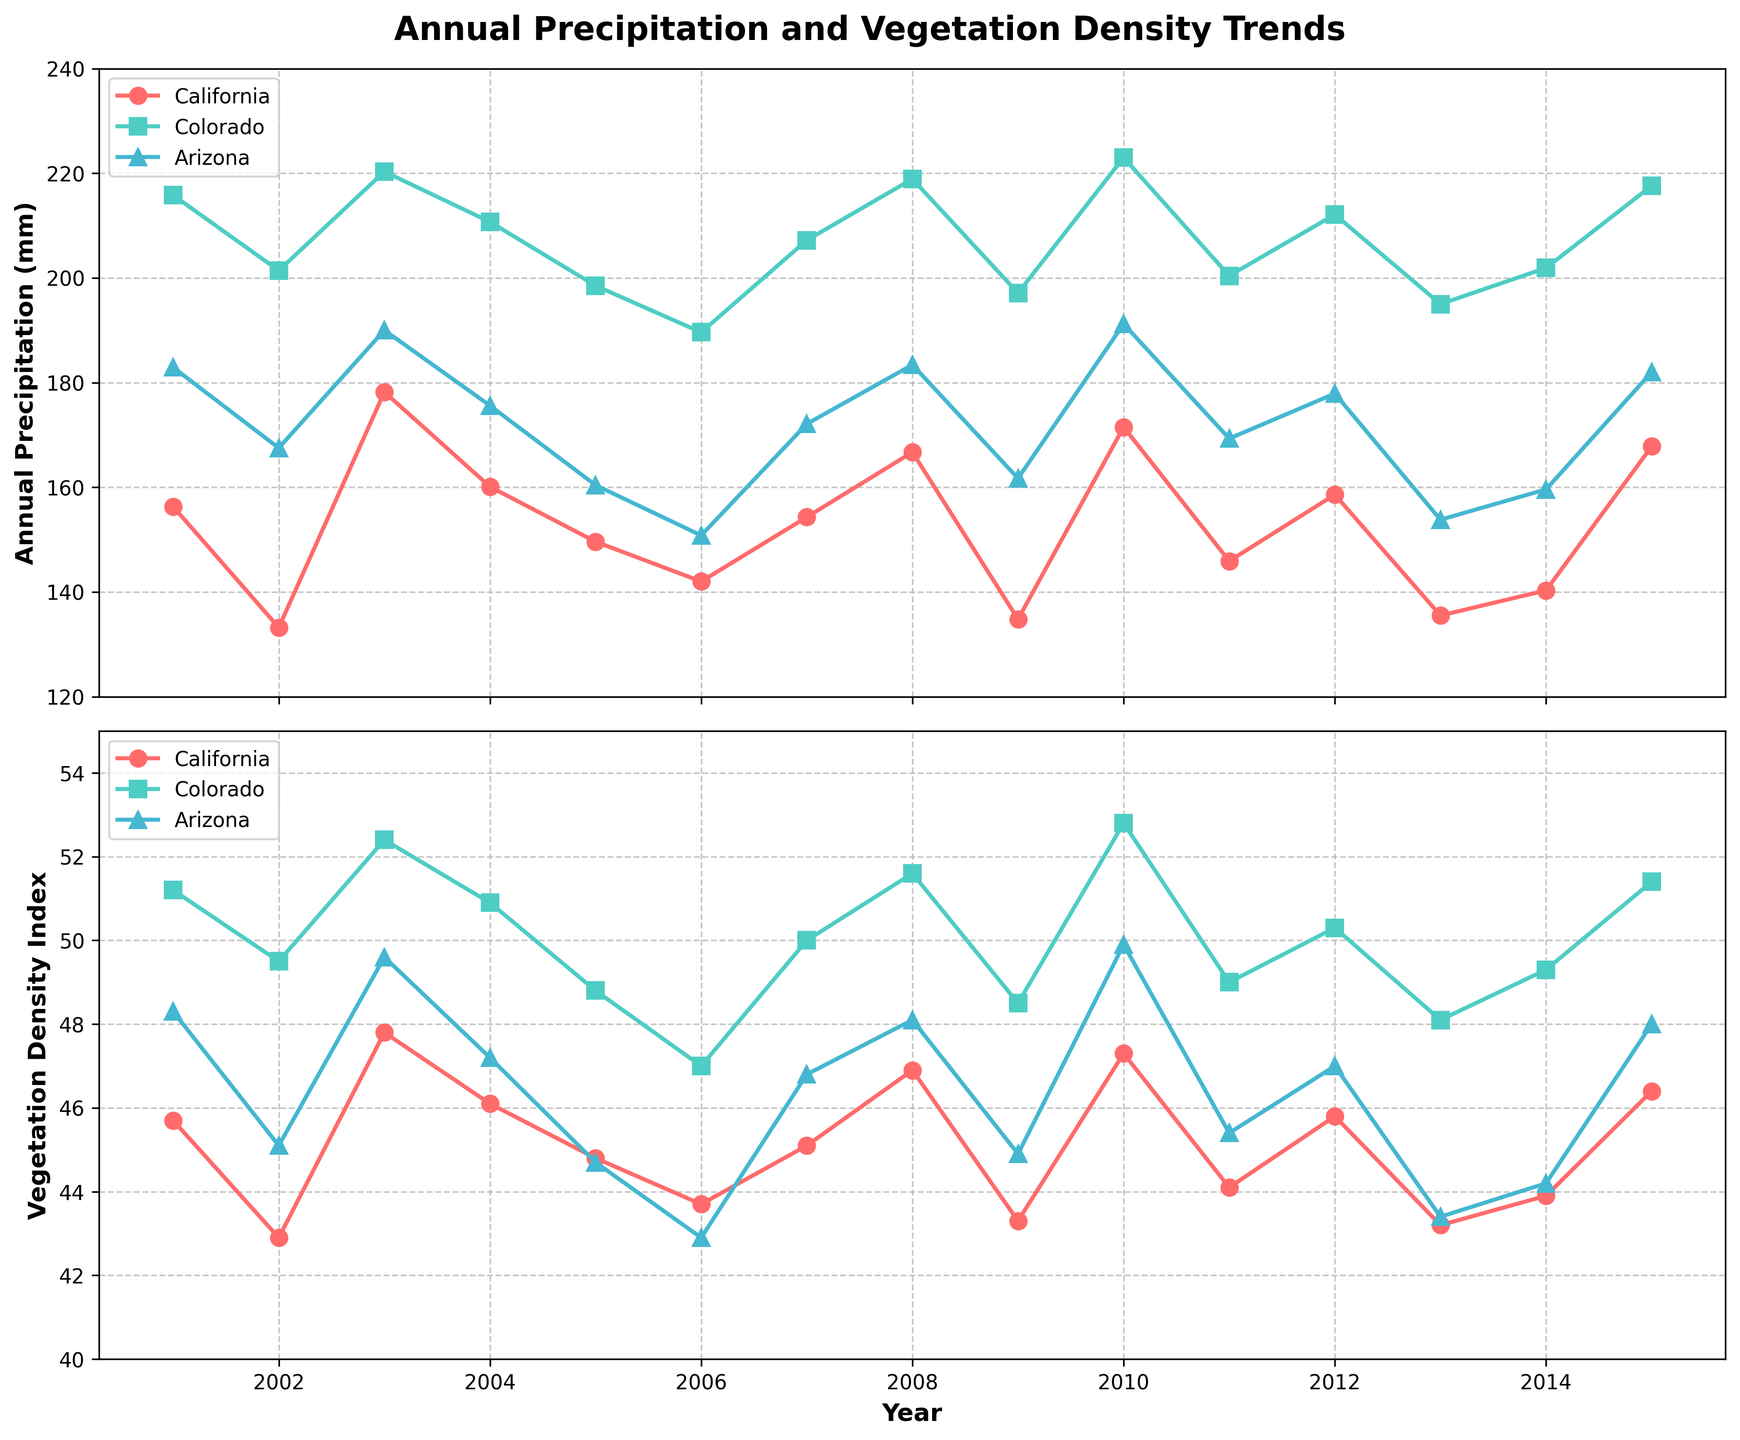What's the title of the plot? The title is usually found at the top of the figure. For this plot, it reads 'Annual Precipitation and Vegetation Density Trends'.
Answer: Annual Precipitation and Vegetation Density Trends How many regions are plotted in the figure? The legend shows three different labels, each representing a region. These are California, Colorado, and Arizona.
Answer: 3 Which region had the highest Annual Precipitation in 2010? Look at the point for 2010 on the Annual Precipitation plot. The highest value is indicated by the line that is at the top, which is Colorado.
Answer: Colorado On average, which region shows the highest Vegetation Density Index over the years? Calculate the average Vegetation Density Index for each region from the plot. Visually, Colorado generally has higher values compared to California and Arizona.
Answer: Colorado In which year did California experience the lowest Annual Precipitation? Look at the lowest point in the California line on the Annual Precipitation plot. The lowest value for California is in 2009.
Answer: 2009 How does the Vegetation Density Index in California in 2007 compare to that in 2010? Locate the points for these years on the Vegetation Density Index plot for California. In 2007, the index is slightly lower than in 2010.
Answer: Lower Is there a general trend in the Annual Precipitation for Arizona from 2001 to 2015? Observe the trend line for Arizona on the Annual Precipitation plot. The data appears to fluctuate without a clear increasing or decreasing trend, suggesting no strong overall trend.
Answer: No clear trend Which year saw the highest Vegetation Density Index for Colorado? Look for the highest point in the Colorado line on the Vegetation Density Index plot. This peak occurs in 2010.
Answer: 2010 What is the relationship between Annual Precipitation and Vegetation Density Index for California in 2002? Check the values for Annual Precipitation and Vegetation Density Index for California in 2002 from both plots. Lower precipitation corresponds to a lower vegetation density.
Answer: Both are lower In general, does higher Annual Precipitation correlate with higher Vegetation Density Index for Arizona? By comparing the trends for Arizona on both plots, it appears that years with higher precipitation generally correspond to higher vegetation density, indicating a positive correlation.
Answer: Yes 